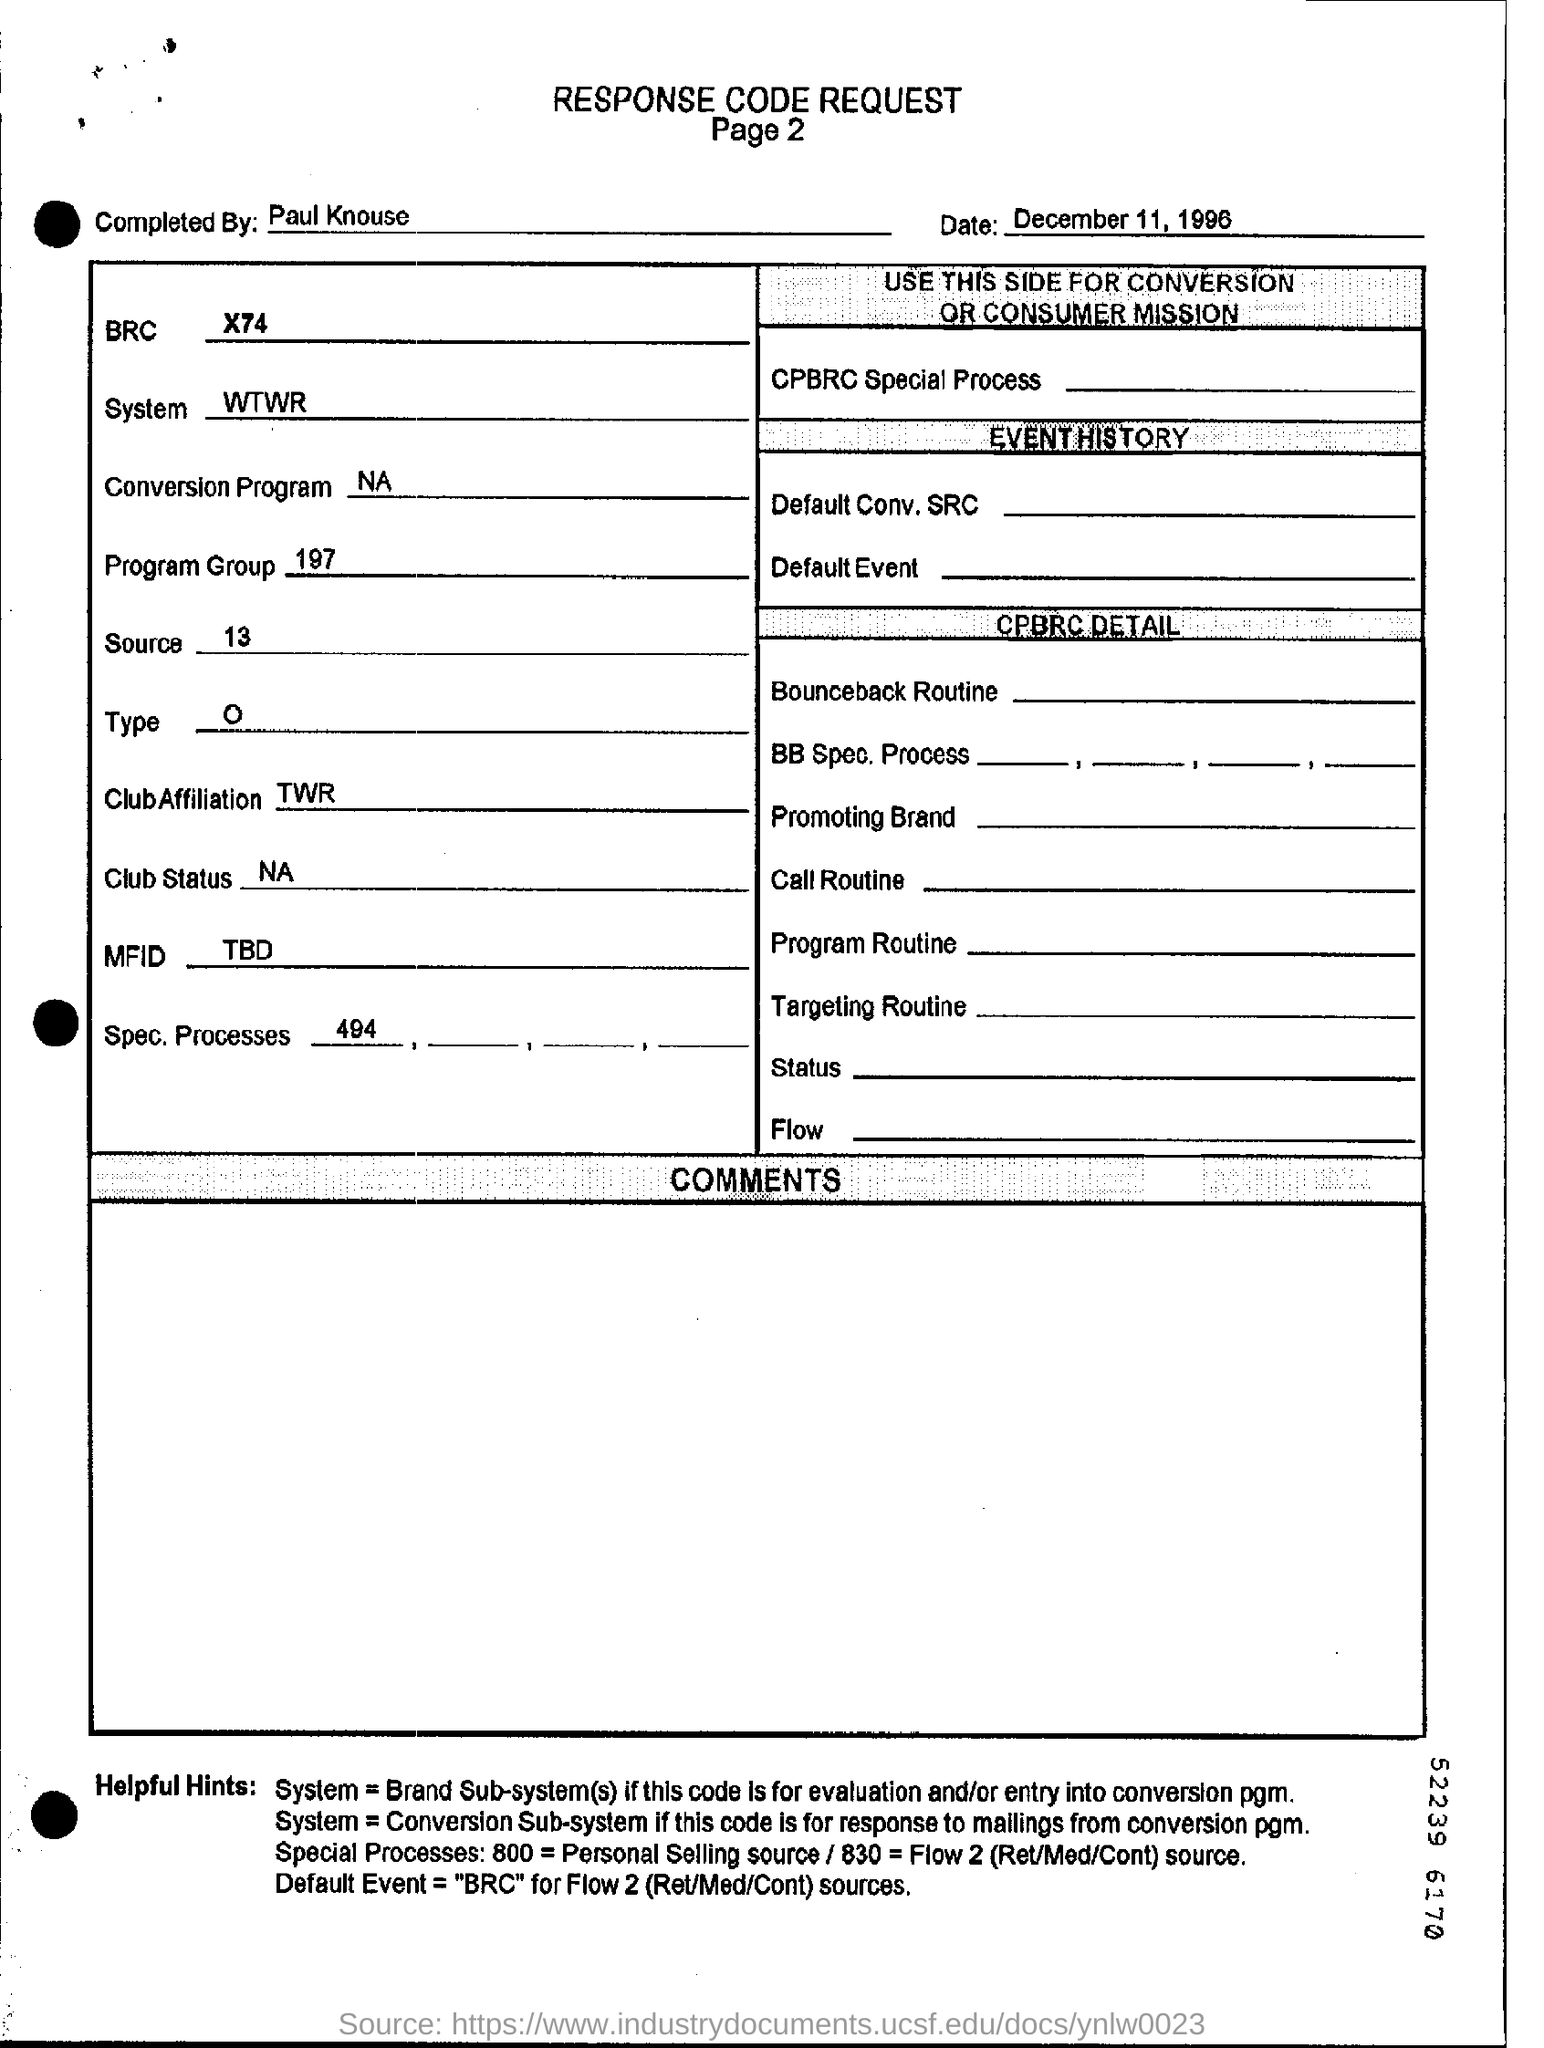Who completed the request  form?
Your answer should be very brief. Paul Knouse. What is the date of the request form?
Offer a very short reply. December 11, 1996. 